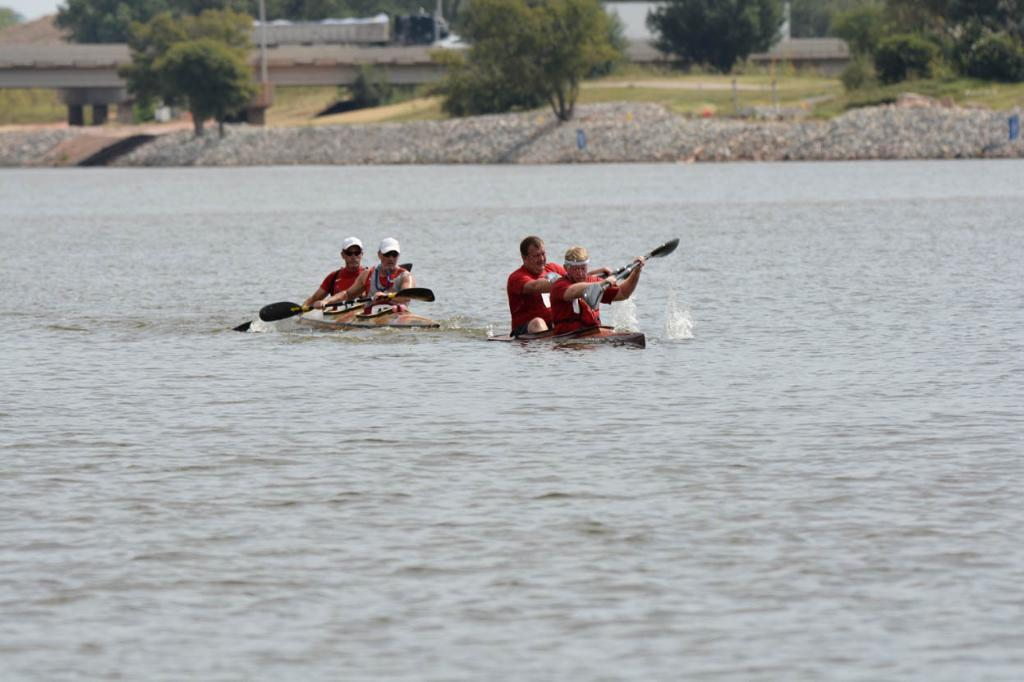What are the persons in the foreground of the image doing? The persons in the foreground of the image are doing kayaking on the water. What are the persons holding while kayaking? They are holding paddles. What can be seen in the background of the image? There are trees, a vehicle moving on a bridge, and the sky visible in the background of the image. How many babies are present in the image? There are no babies present in the image; it features persons kayaking on the water. What type of government is depicted in the image? There is no depiction of a government in the image; it focuses on persons kayaking and the surrounding environment. 